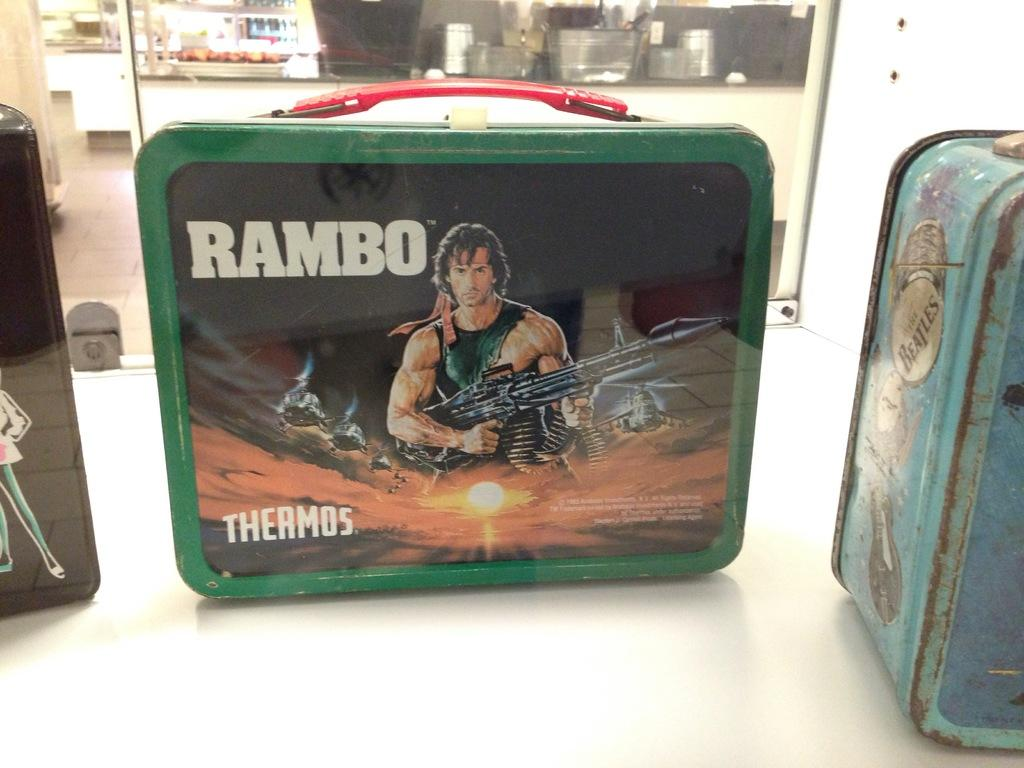What is located in the middle of the image? There is a bag in the middle of the image. What is the man in the image doing? The man is holding a weapon in the image. What object can be seen on the right side of the image? There appears to be an iron box on the right side of the image. What type of ice can be seen melting on the weapon in the image? There is no ice present in the image, and the weapon is not associated with any melting ice. How does the ink on the iron box affect its appearance in the image? There is no ink mentioned or visible on the iron box in the image. 